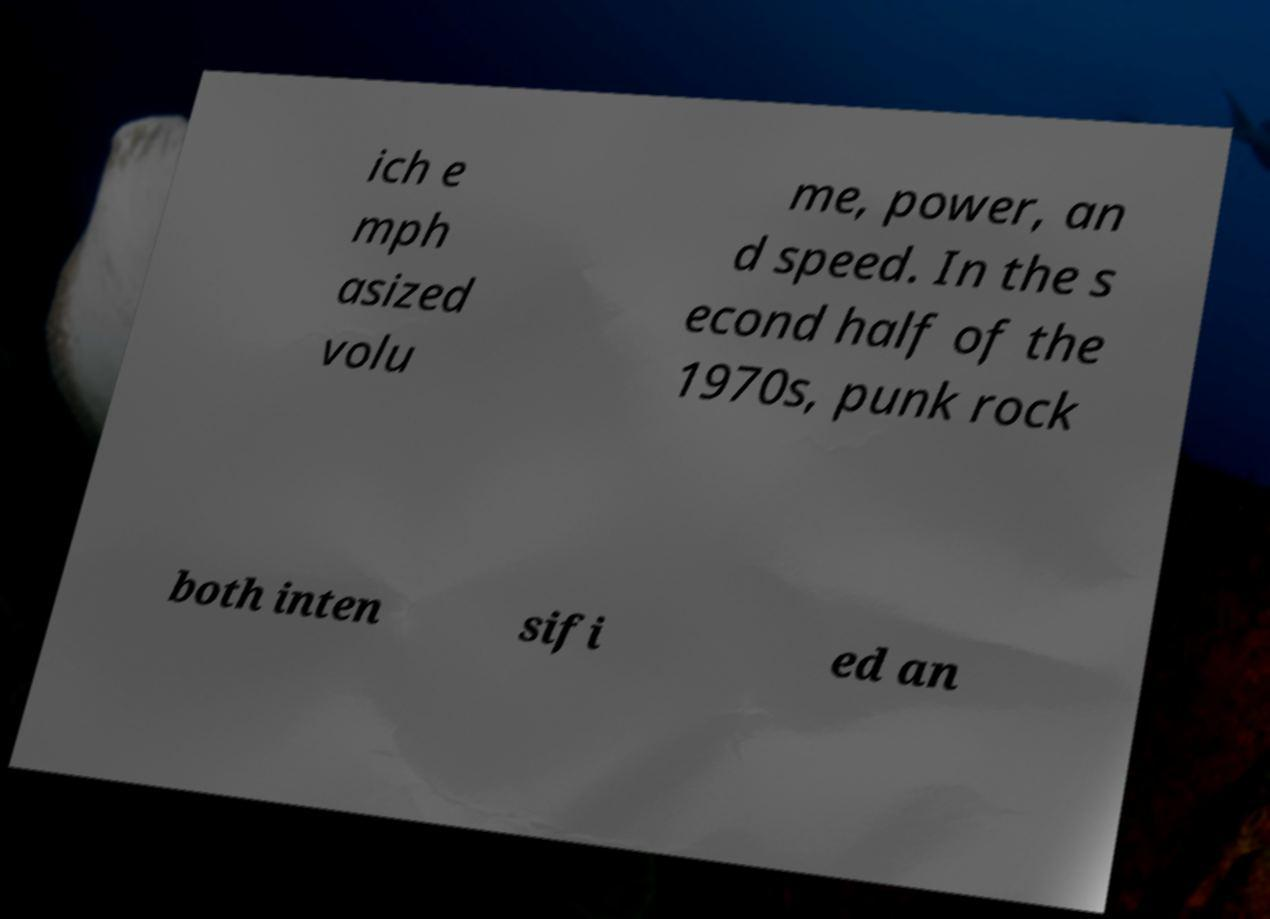Could you extract and type out the text from this image? ich e mph asized volu me, power, an d speed. In the s econd half of the 1970s, punk rock both inten sifi ed an 